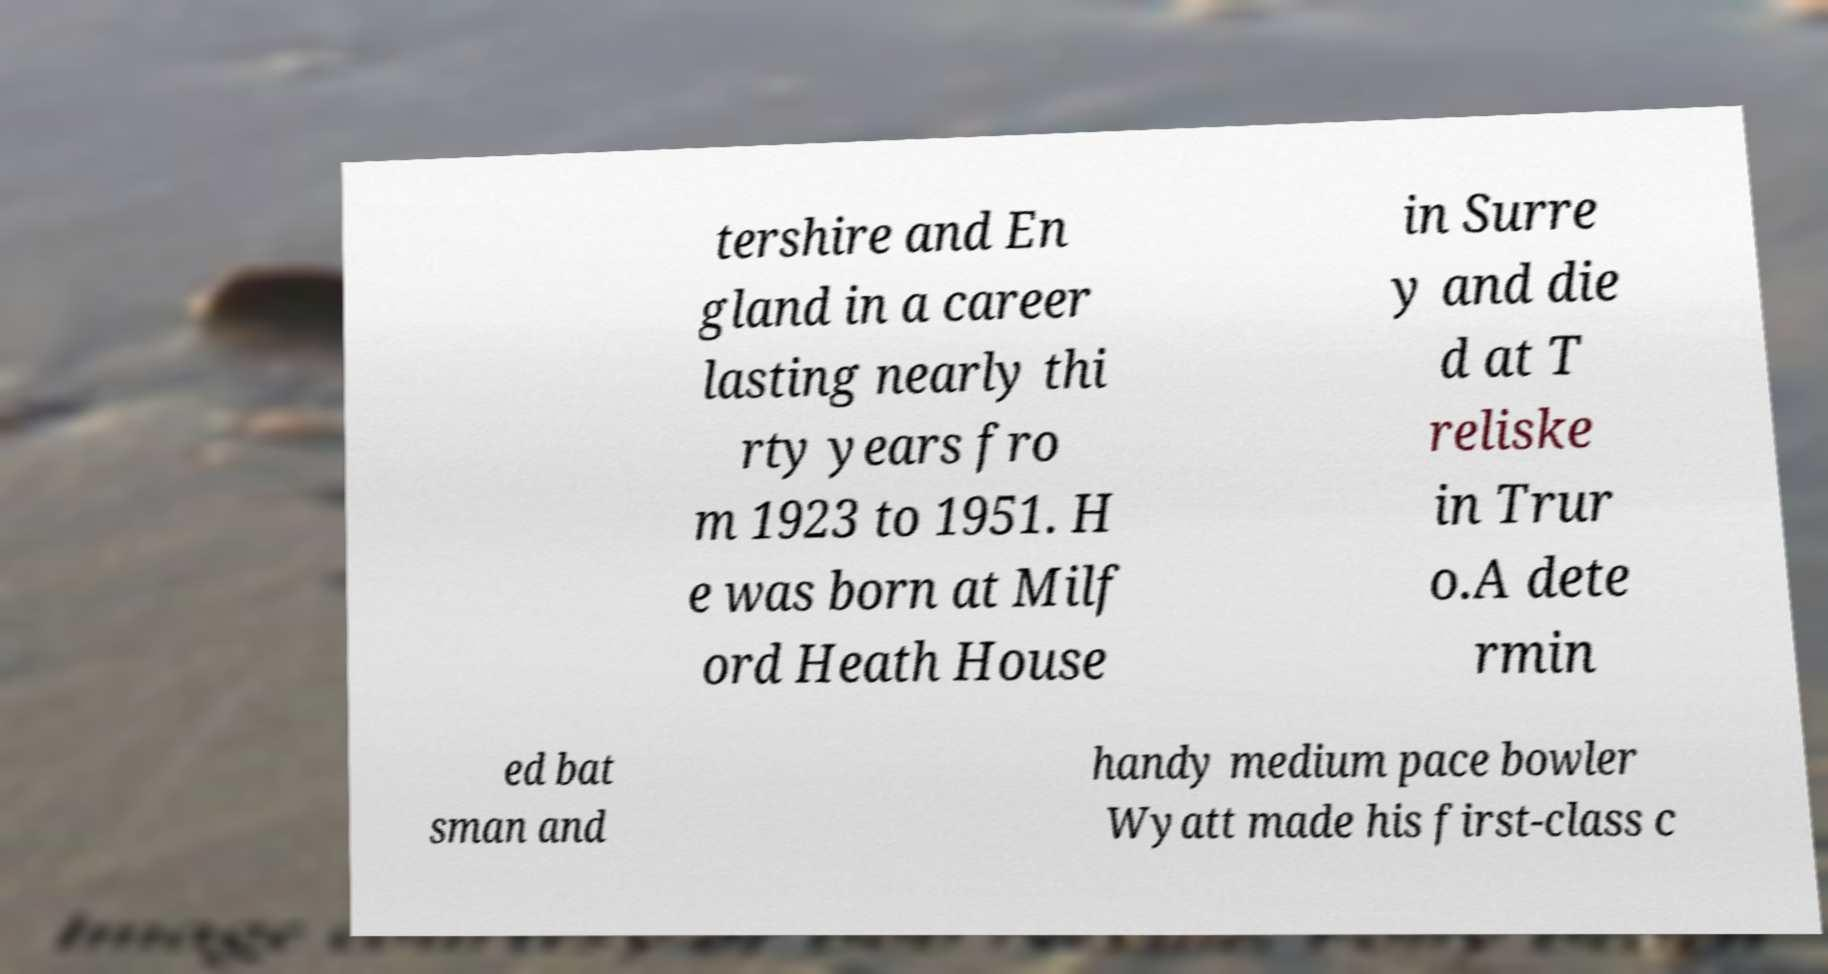I need the written content from this picture converted into text. Can you do that? tershire and En gland in a career lasting nearly thi rty years fro m 1923 to 1951. H e was born at Milf ord Heath House in Surre y and die d at T reliske in Trur o.A dete rmin ed bat sman and handy medium pace bowler Wyatt made his first-class c 